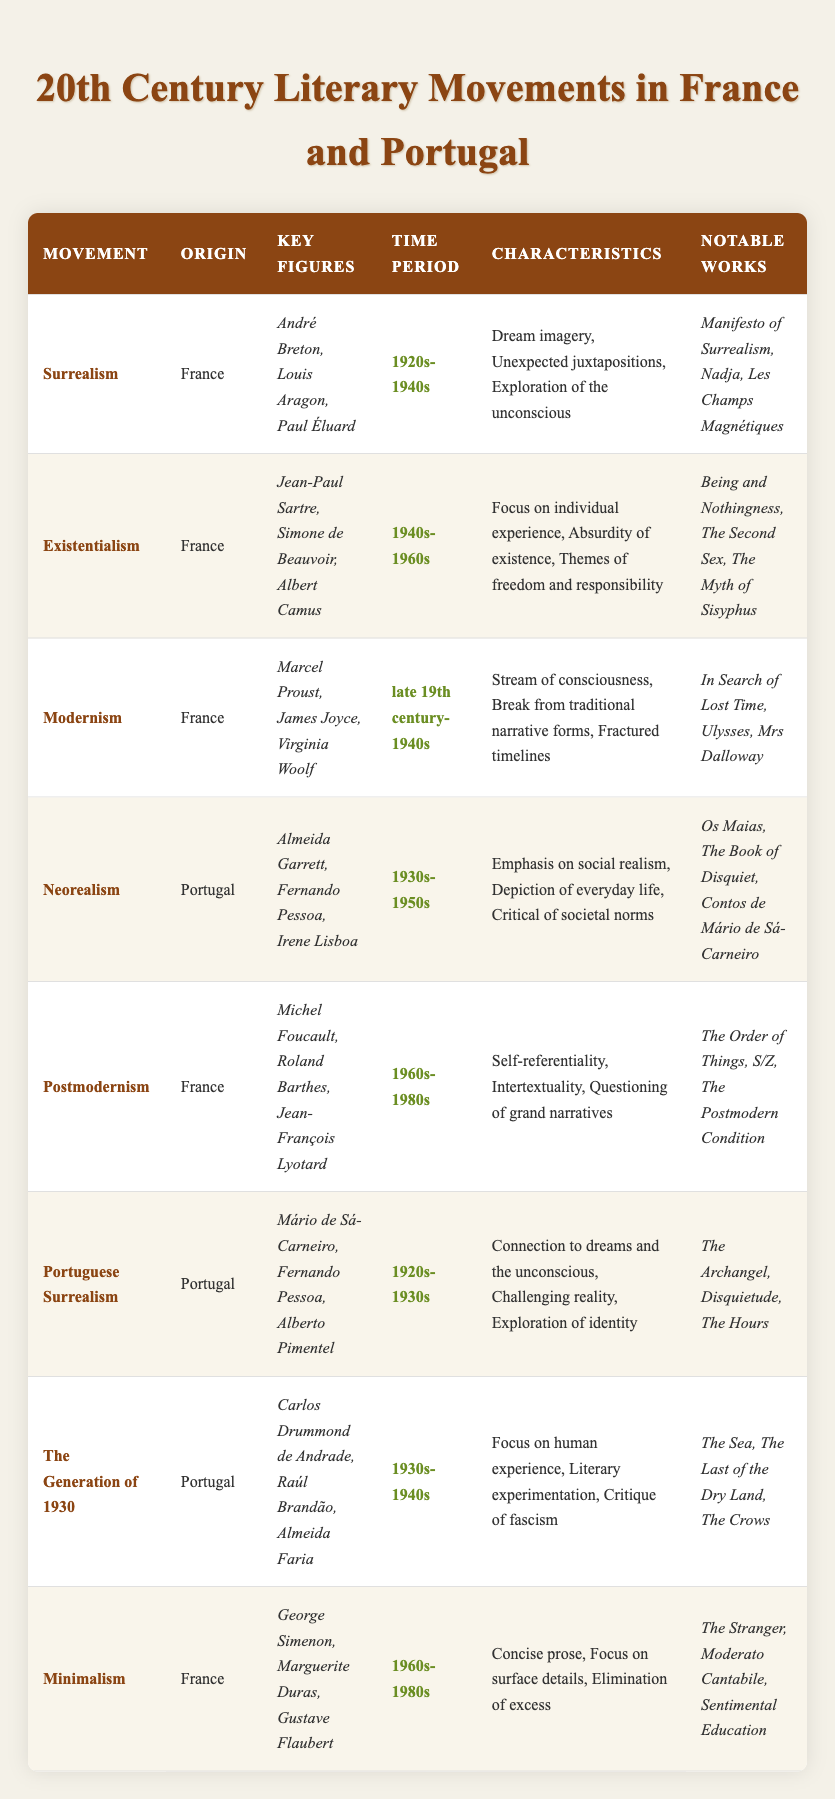What are the key figures of Existentialism? The table lists the key figures for Existentialism as Jean-Paul Sartre, Simone de Beauvoir, and Albert Camus. This information can be directly retrieved from the corresponding row in the table under the "Key Figures" column.
Answer: Jean-Paul Sartre, Simone de Beauvoir, Albert Camus Which literary movement originated in Portugal and focuses on social realism? In the table, the literary movement listed under Portugal that emphasizes social realism is Neorealism. This is found in the entry for Neorealism, specifically in the "Origin" and "Characteristics" columns.
Answer: Neorealism How many movements originated in Portugal? By counting the entries listed under the "Origin" column where the value is Portugal, we find that there are four such movements: Neorealism, Portuguese Surrealism, The Generation of 1930, and Modernism.
Answer: Four Is Surrealism characterized by exploration of the unconscious? The table indicates that one of the characteristics of Surrealism is "Exploration of the unconscious." This can be confirmed by reviewing the "Characteristics" column for that movement.
Answer: Yes Which movement has the time period "1960s-1980s" and involves self-referentiality? The movement referred to is Postmodernism. The "Time Period" and "Characteristics" columns for Postmodernism state 1960s-1980s and self-referentiality, respectively. This requires identifying the correct movement based on its characteristics and temporal range.
Answer: Postmodernism What are the notable works of Portuguese Surrealism? The table specifies the notable works associated with Portuguese Surrealism as "The Archangel," "Disquietude," and "The Hours." This information is directly available in the "Notable Works" column for the Portuguese Surrealism entry.
Answer: The Archangel, Disquietude, The Hours Which of the movements includes Virginia Woolf as a key figure? Looking at the table, Virginia Woolf is associated with the Modernism movement, where she is listed under the "Key Figures" column. This requires checking the relevant row to find her name linked with Modernism.
Answer: Modernism What is the difference between the time periods of Minimalism and Surrealism? Minimalism spans the years 1960s-1980s, and Surrealism spans 1920s-1940s. To find the difference, we observe the two periods and note that Minimalism starts about 20 years after Surrealism ends. Thus, the difference in years is from the end of Surrealism to the beginning of Minimalism: 1960 - 1940 = 20 years.
Answer: 20 years What are the characteristics of Neorealism? The table lists the characteristics of Neorealism as "Emphasis on social realism," "Depiction of everyday life," and "Critical of societal norms." This information can be directly retrieved from the "Characteristics" column under Neorealism.
Answer: Emphasis on social realism, Depiction of everyday life, Critical of societal norms 